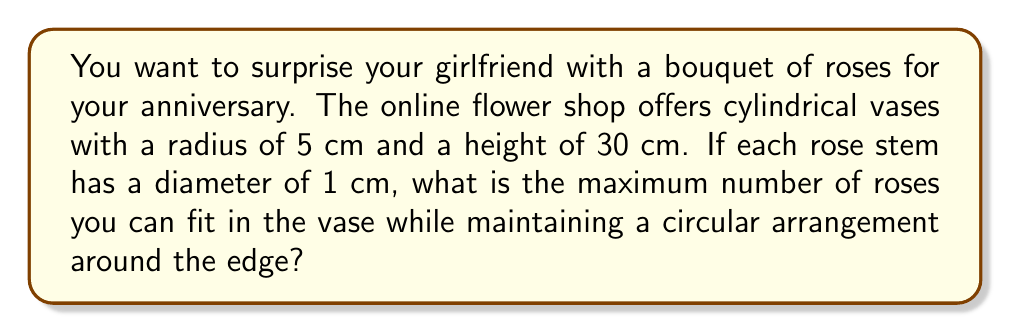Show me your answer to this math problem. Let's approach this step-by-step:

1) First, we need to understand that the roses will be arranged in a circle along the inner edge of the vase. The centers of the rose stems will form a circle with a radius smaller than the vase's radius.

2) Let's call the radius of the circle formed by the centers of the rose stems $r$. This radius will be:
   $r = 5 - 0.5 = 4.5$ cm
   (We subtract 0.5 cm because the radius of each rose stem is 0.5 cm)

3) Now, we need to calculate the circumference of this circle:
   $C = 2\pi r = 2\pi(4.5) \approx 28.27$ cm

4) Each rose stem occupies 1 cm of this circumference. To find the maximum number of roses, we divide the circumference by the diameter of a rose stem:

   $\text{Number of roses} = \frac{C}{1} = \frac{28.27}{1} \approx 28.27$

5) Since we can't have a fractional number of roses, we round down to the nearest whole number.

Therefore, the maximum number of roses that can fit in the vase while maintaining a circular arrangement is 28.
Answer: 28 roses 